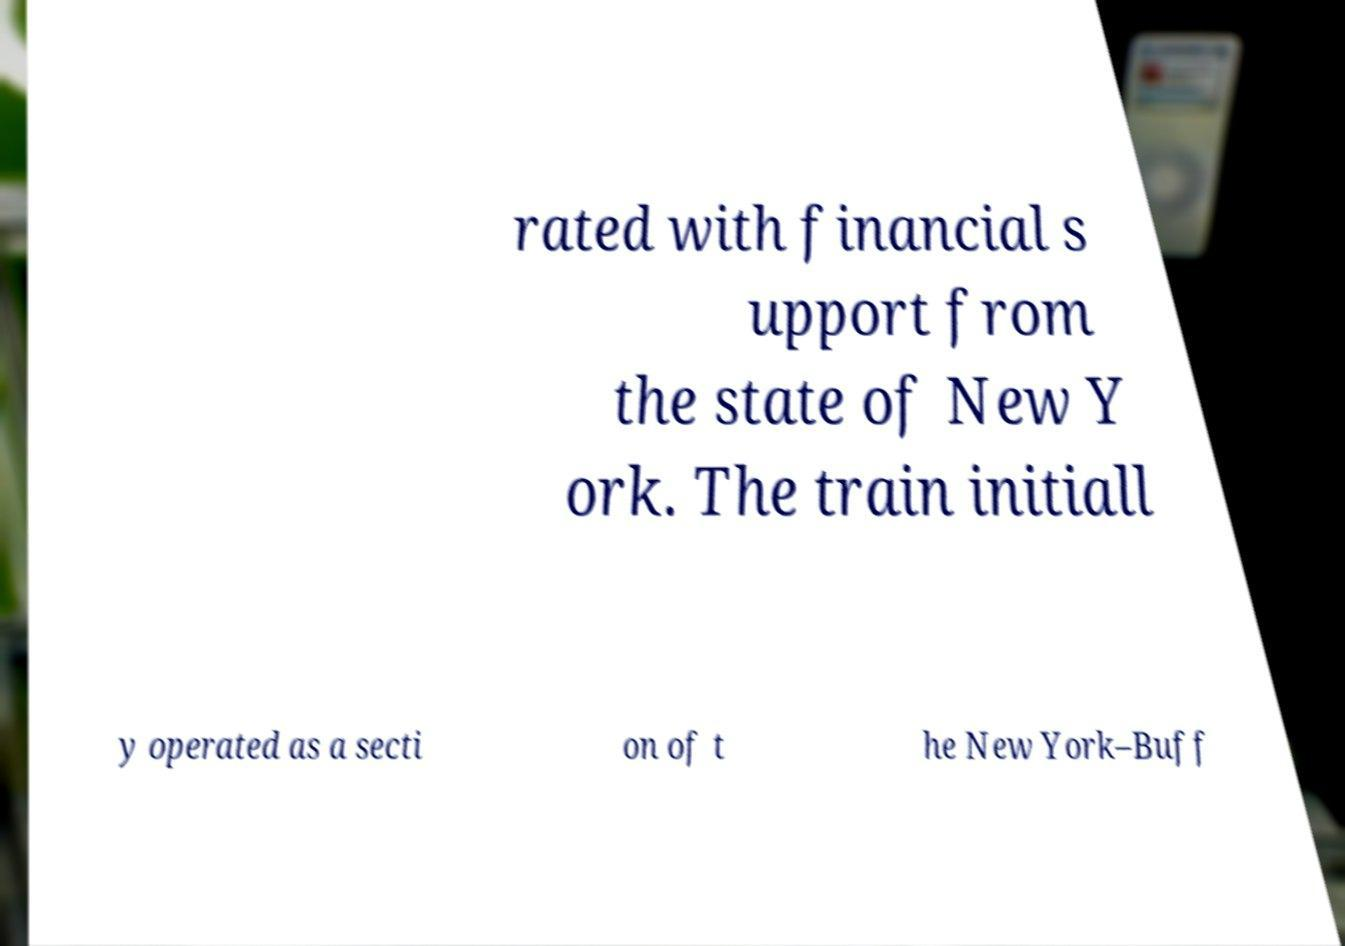For documentation purposes, I need the text within this image transcribed. Could you provide that? rated with financial s upport from the state of New Y ork. The train initiall y operated as a secti on of t he New York–Buff 